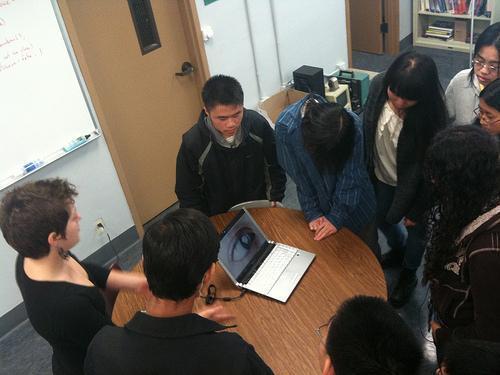How many people are in this photo?
Give a very brief answer. 9. 